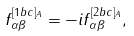Convert formula to latex. <formula><loc_0><loc_0><loc_500><loc_500>f ^ { [ 1 b c ] _ { A } } _ { \alpha \beta } = - i f ^ { [ 2 b c ] _ { A } } _ { \alpha \beta } ,</formula> 